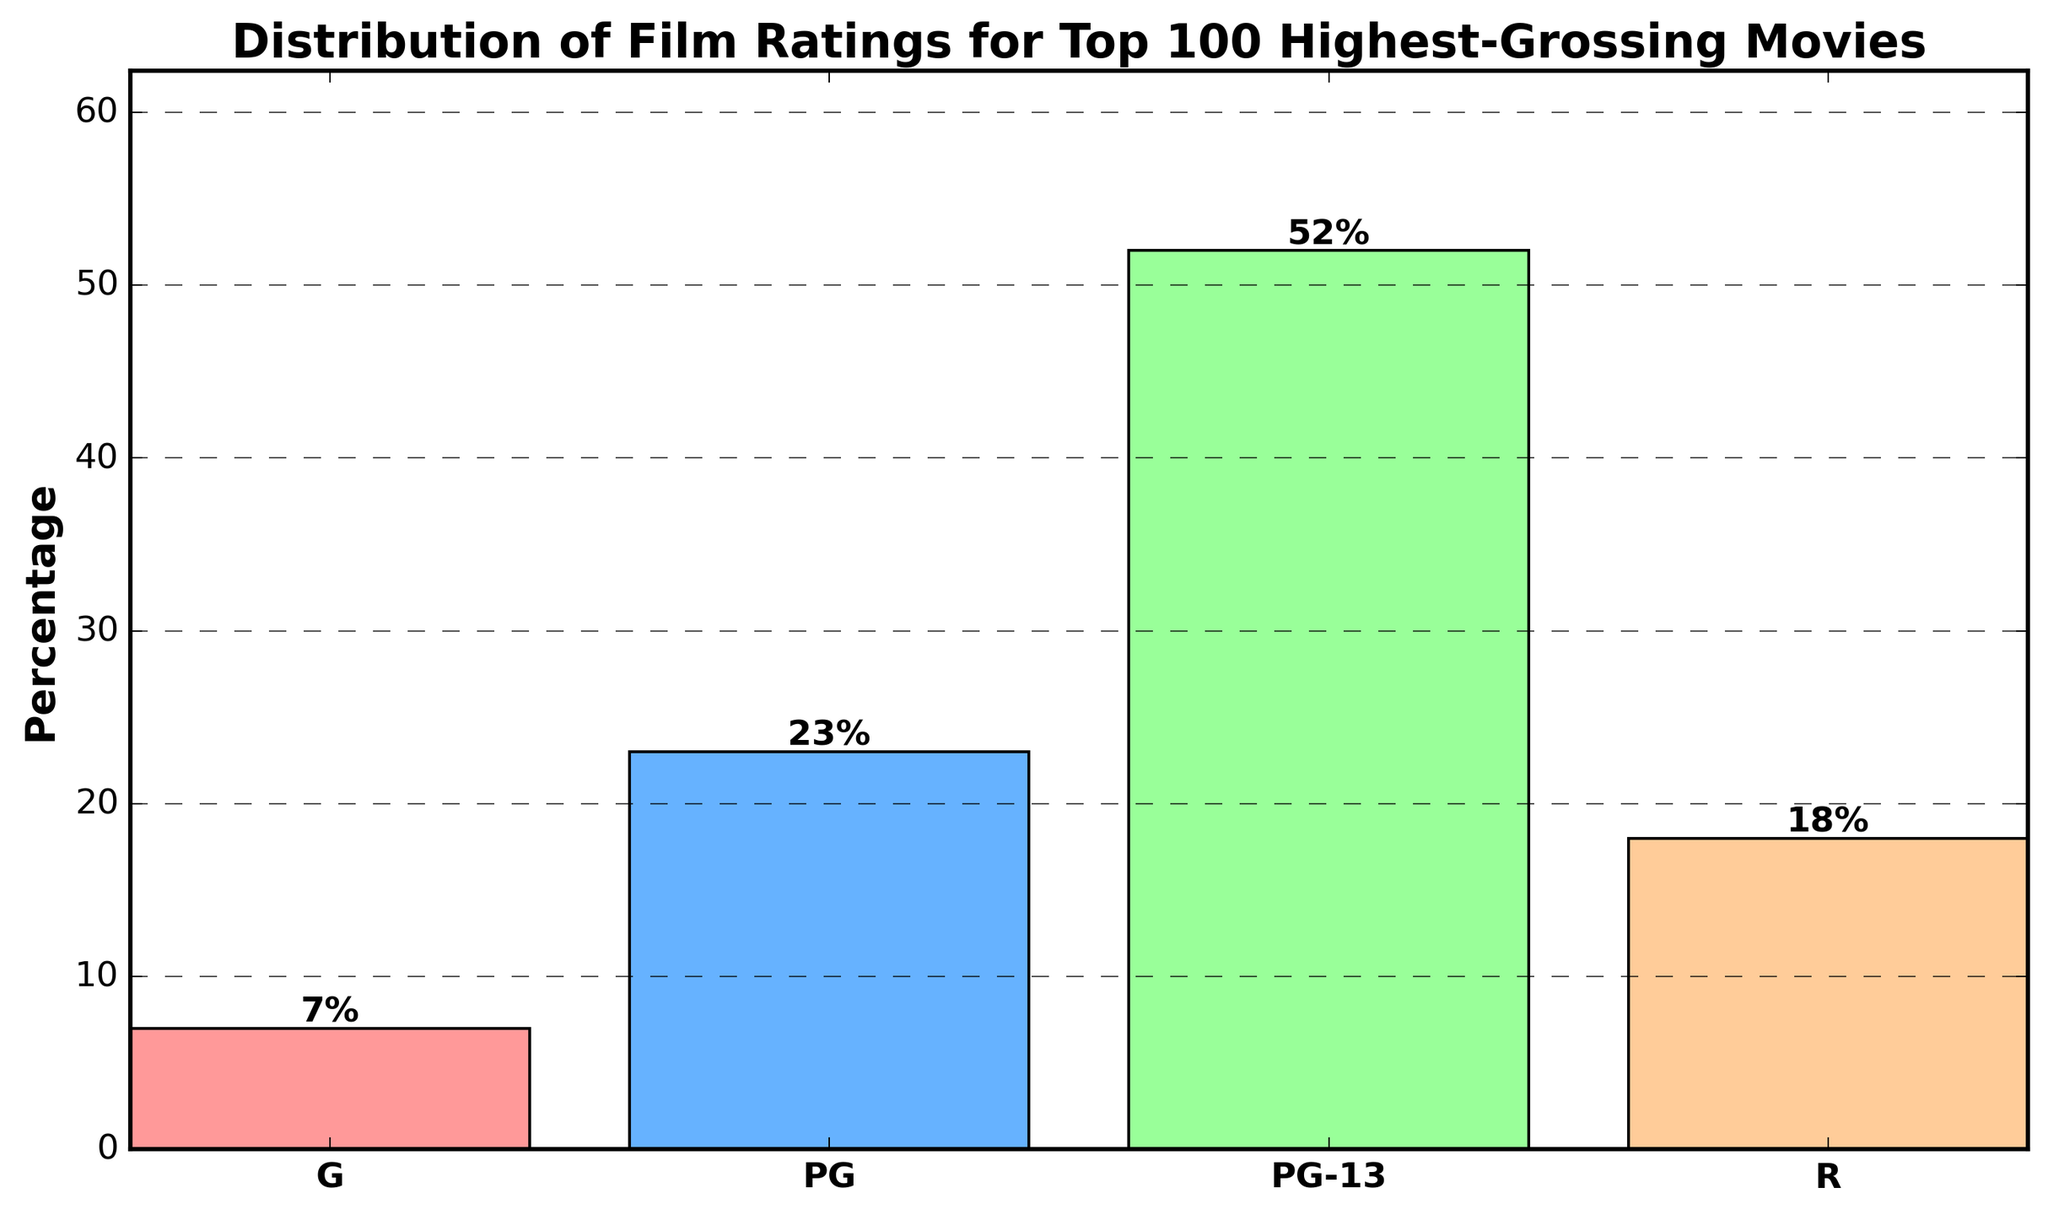What percentage of the top 100 highest-grossing movies are rated PG-13? The figure shows that the bar for PG-13 reaches up to 52%. Therefore, 52% of the top 100 highest-grossing movies are rated PG-13.
Answer: 52% Which film rating category has the least representation? The figure indicates that the smallest bar corresponds to the G rating, which is at 7%. Therefore, the G rating has the least representation.
Answer: G By what percentage does the representation of PG-13 rated films exceed that of R rated films? The bar for PG-13 is at 52%, and the bar for R is at 18%. The difference is calculated as 52% - 18% = 34%. Therefore, PG-13 rated films exceed R rated films by 34%.
Answer: 34% What is the combined percentage of G and PG rated films? The G rated films are at 7% and the PG rated films are at 23%. Adding these together gives 7% + 23% = 30%. Therefore, the combined percentage is 30%.
Answer: 30% How much higher is the percentage of PG-13 rated films compared to PG rated films? The PG-13 rating has a percentage of 52%, while the PG rating has 23%. The difference is calculated as 52% - 23% = 29%. Therefore, PG-13 films are 29% higher than PG films.
Answer: 29% What percentage of films are either G or R rated? The G rated films are at 7%, and the R rated films are at 18%. Adding these together gives 7% + 18% = 25%. Therefore, the percentage of films that are either G or R rated is 25%.
Answer: 25% Which rating has more films: PG or R? The figure shows that the PG bar is at 23%, while the R bar is at 18%. Therefore, there are more PG rated films than R rated films.
Answer: PG What is the height of the bar for the G rating? The figure shows that the bar for the G rating reaches a height corresponding to 7%. Therefore, the height is 7%.
Answer: 7% Is the percentage of PG-13 rated films more than half of the top 100 highest-grossing movies? The bar for PG-13 rating shows a percentage of 52%. Since 52% is greater than 50%, more than half of the top 100 highest-grossing movies are PG-13 rated.
Answer: Yes 